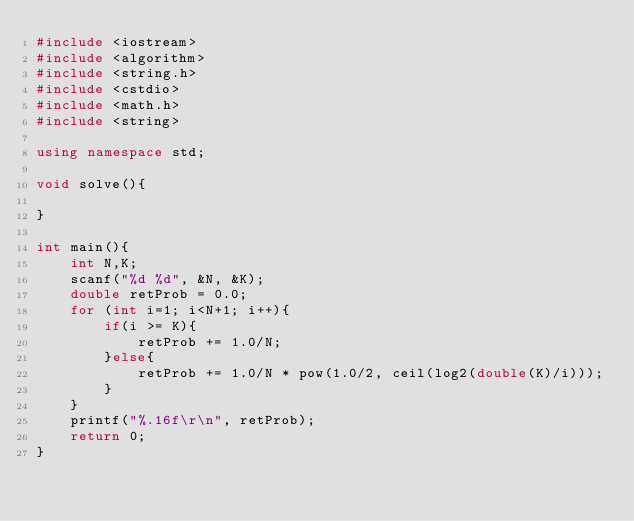<code> <loc_0><loc_0><loc_500><loc_500><_C++_>#include <iostream>
#include <algorithm>
#include <string.h>
#include <cstdio>
#include <math.h>
#include <string>

using namespace std;

void solve(){

}

int main(){
    int N,K;
    scanf("%d %d", &N, &K);
    double retProb = 0.0;
    for (int i=1; i<N+1; i++){
        if(i >= K){
            retProb += 1.0/N;
        }else{
            retProb += 1.0/N * pow(1.0/2, ceil(log2(double(K)/i)));
        }
    }
    printf("%.16f\r\n", retProb);
    return 0;
}</code> 